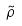Convert formula to latex. <formula><loc_0><loc_0><loc_500><loc_500>\tilde { \rho }</formula> 